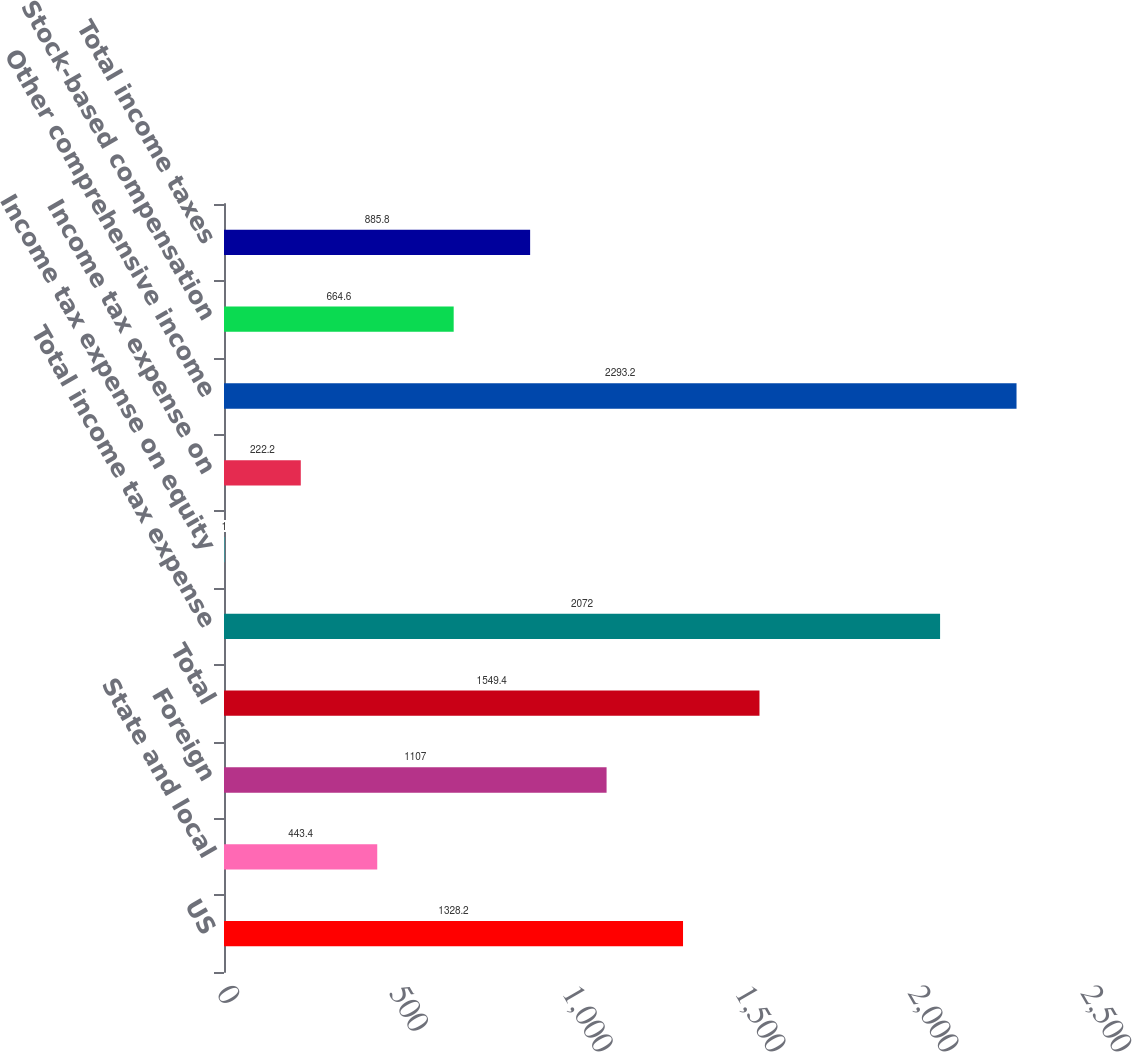Convert chart. <chart><loc_0><loc_0><loc_500><loc_500><bar_chart><fcel>US<fcel>State and local<fcel>Foreign<fcel>Total<fcel>Total income tax expense<fcel>Income tax expense on equity<fcel>Income tax expense on<fcel>Other comprehensive income<fcel>Stock-based compensation<fcel>Total income taxes<nl><fcel>1328.2<fcel>443.4<fcel>1107<fcel>1549.4<fcel>2072<fcel>1<fcel>222.2<fcel>2293.2<fcel>664.6<fcel>885.8<nl></chart> 